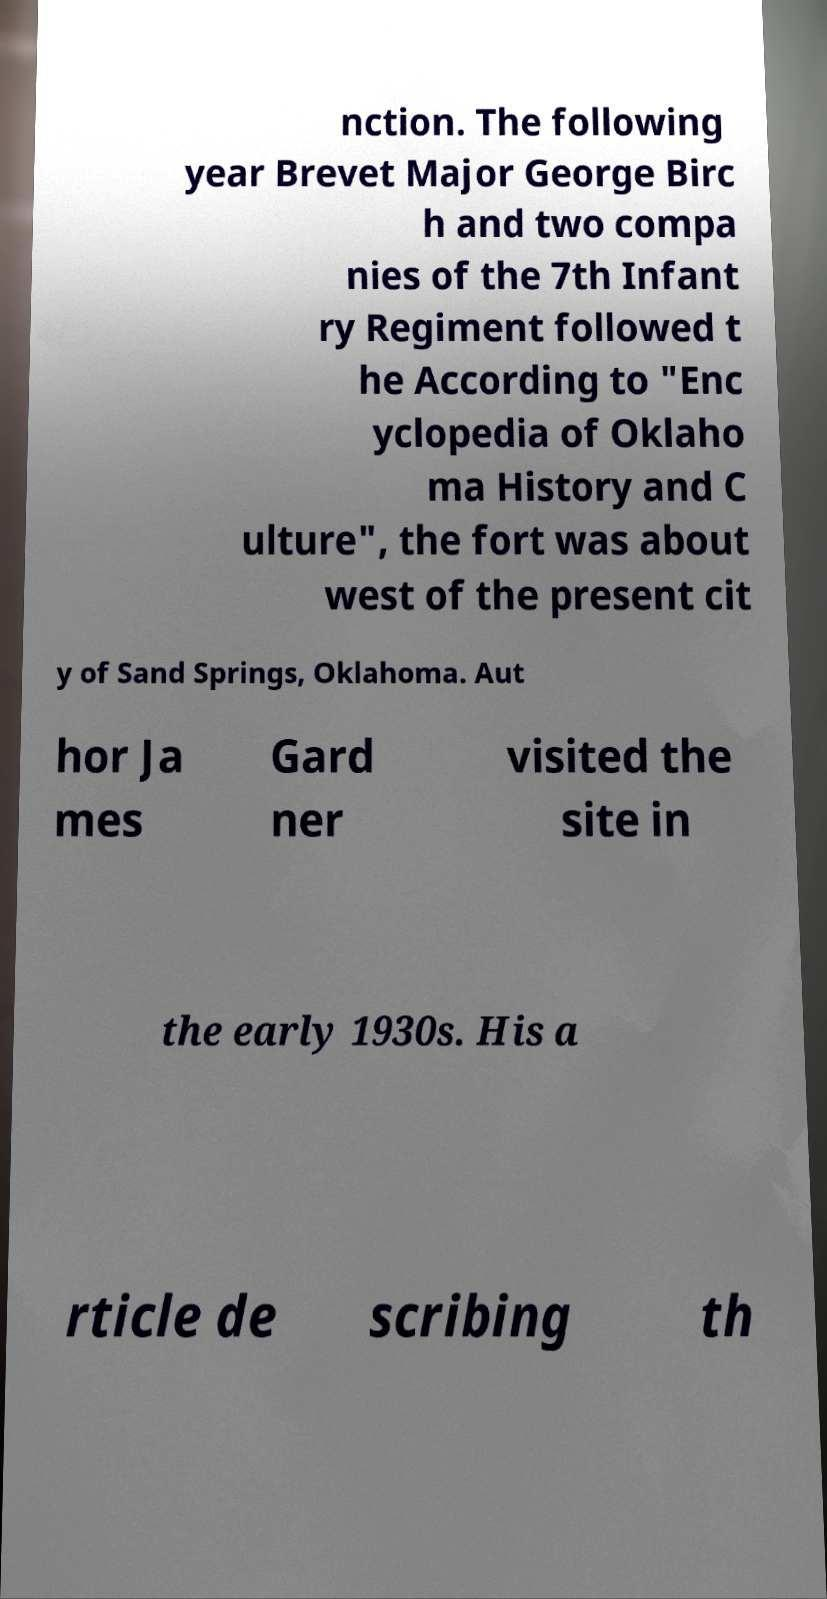Could you extract and type out the text from this image? nction. The following year Brevet Major George Birc h and two compa nies of the 7th Infant ry Regiment followed t he According to "Enc yclopedia of Oklaho ma History and C ulture", the fort was about west of the present cit y of Sand Springs, Oklahoma. Aut hor Ja mes Gard ner visited the site in the early 1930s. His a rticle de scribing th 